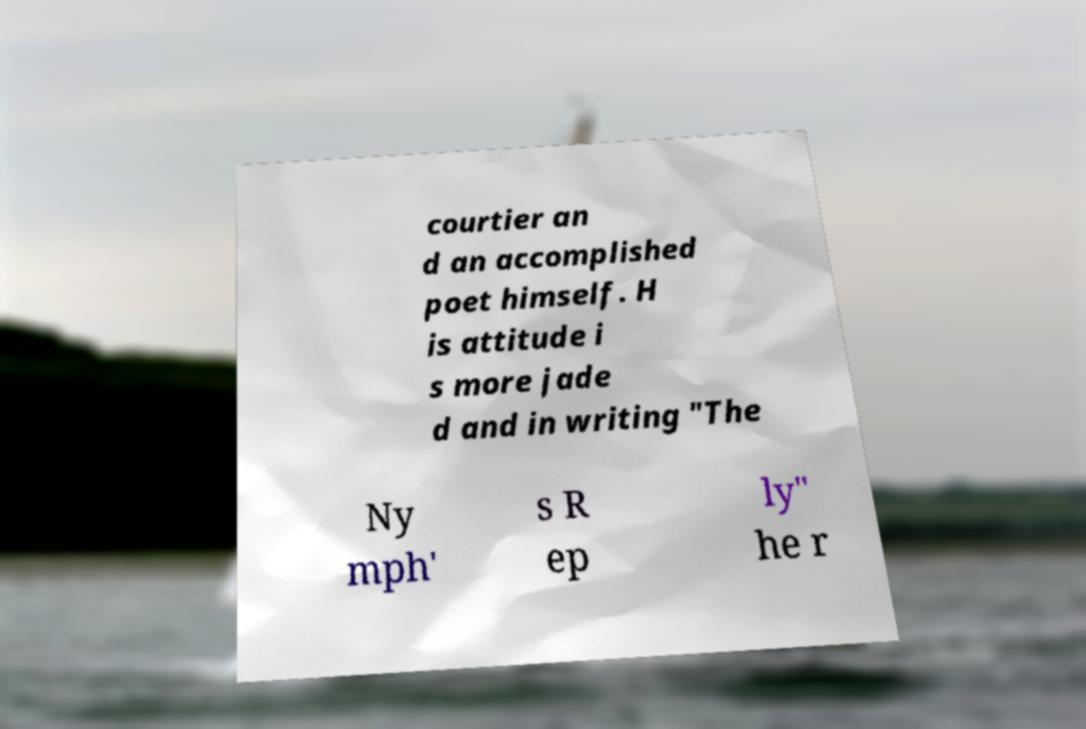I need the written content from this picture converted into text. Can you do that? courtier an d an accomplished poet himself. H is attitude i s more jade d and in writing "The Ny mph' s R ep ly" he r 